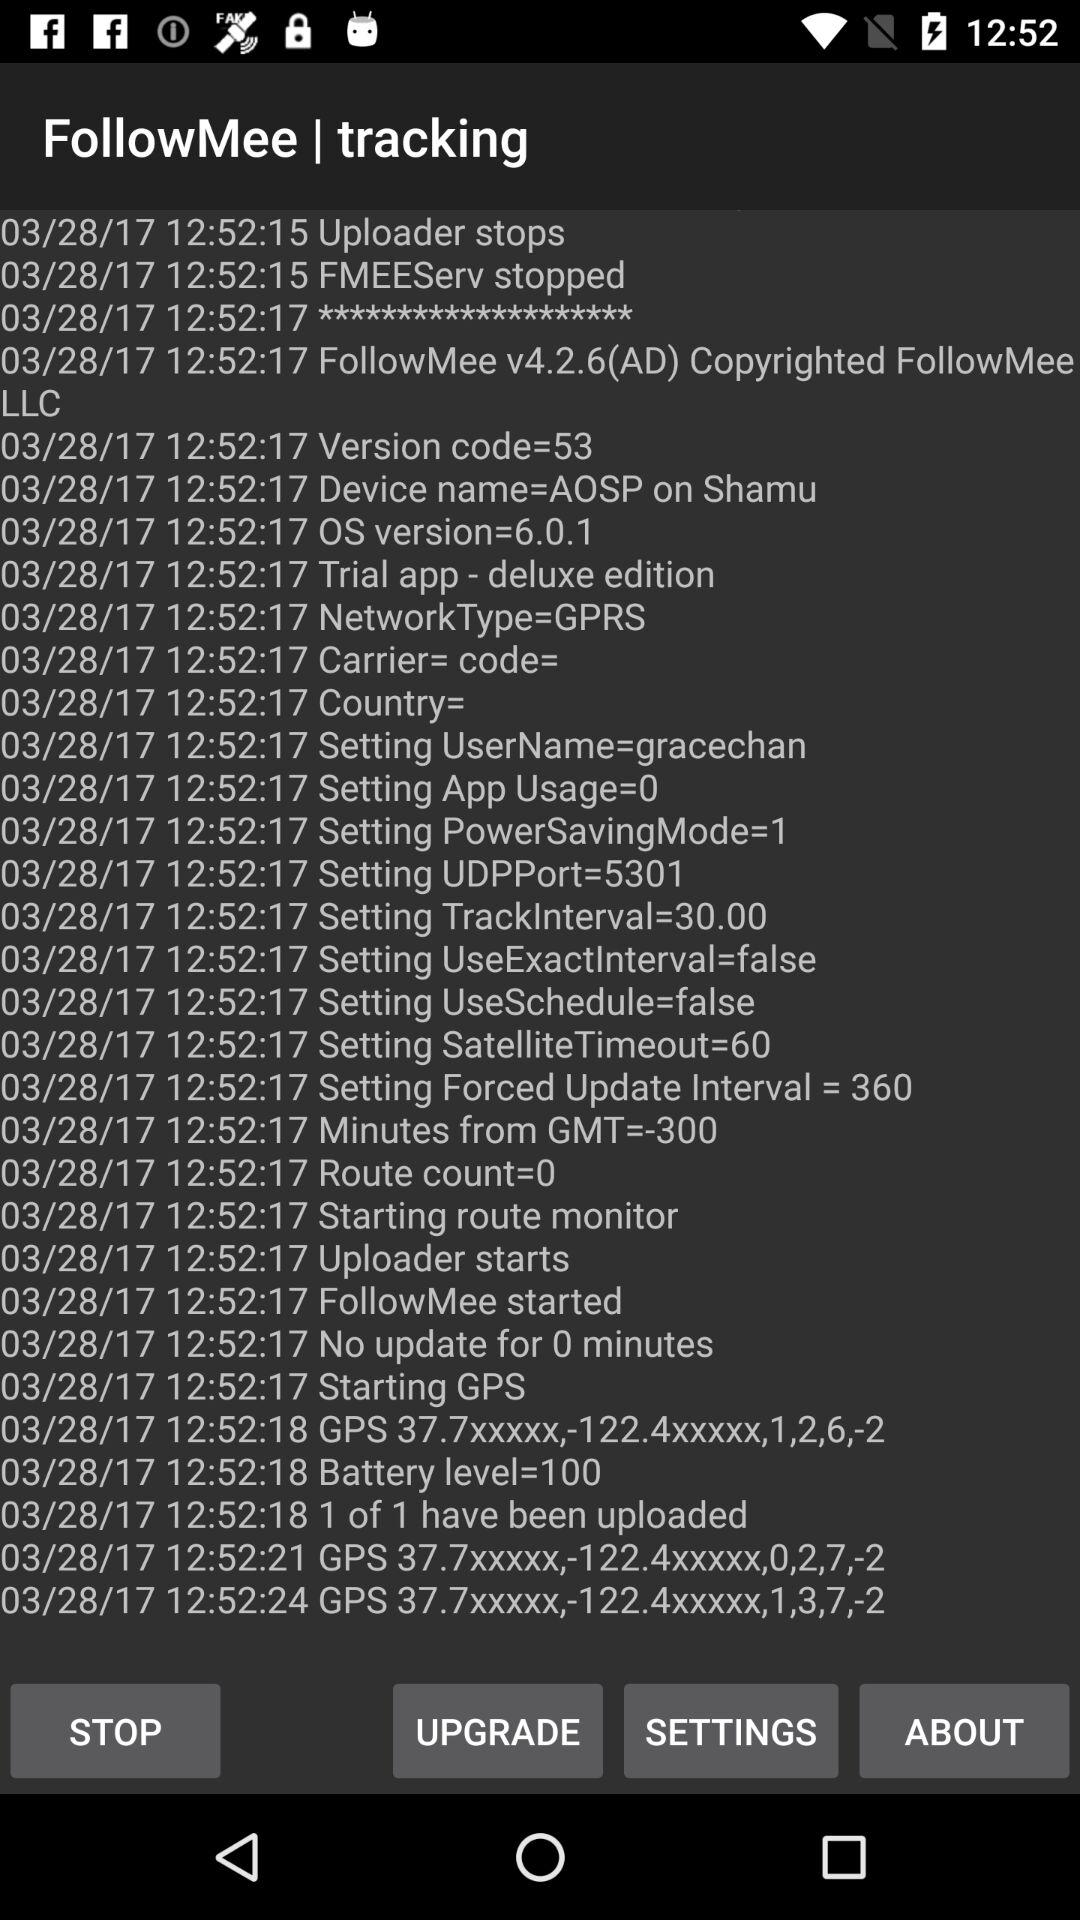What's the OS version? The OS version is 6.0.1. 